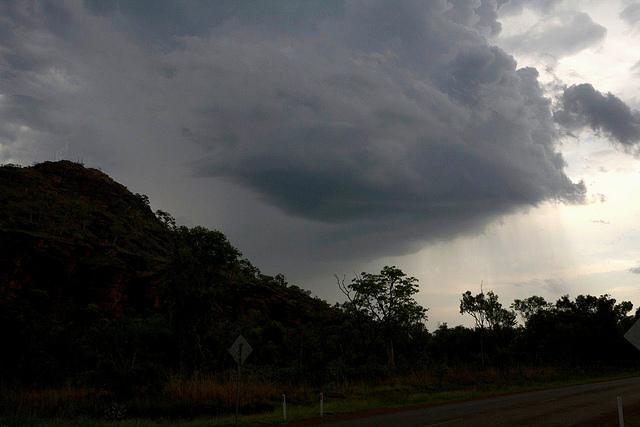How many people can be seen?
Give a very brief answer. 0. 